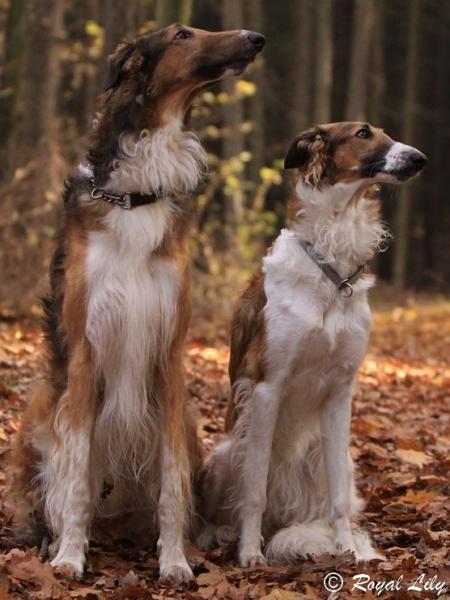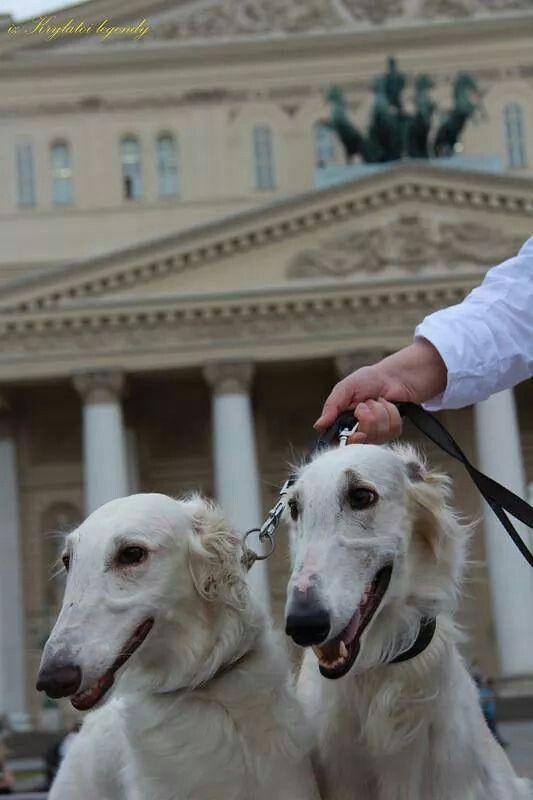The first image is the image on the left, the second image is the image on the right. Examine the images to the left and right. Is the description "One image shows at least one large dog with a handler at a majestic building, while the other image of at least two dogs is set in a rustic outdoor area." accurate? Answer yes or no. Yes. The first image is the image on the left, the second image is the image on the right. Considering the images on both sides, is "An image shows a human hand next to the head of a hound posed in front of ornate architecture." valid? Answer yes or no. Yes. 